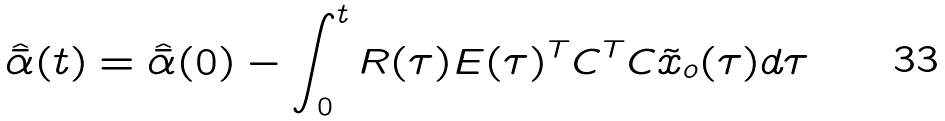<formula> <loc_0><loc_0><loc_500><loc_500>\hat { \bar { \alpha } } ( t ) = \hat { \bar { \alpha } } ( 0 ) - \int _ { 0 } ^ { t } R ( \tau ) E ( \tau ) ^ { T } C ^ { T } C \tilde { x } _ { o } ( \tau ) d \tau</formula> 